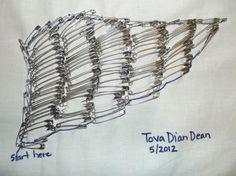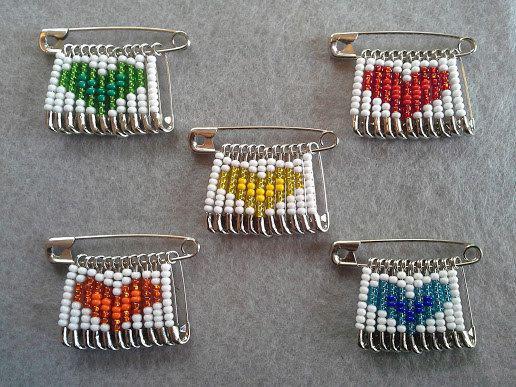The first image is the image on the left, the second image is the image on the right. Examine the images to the left and right. Is the description "One image contains a person wearing a black jacket with a bird design on it." accurate? Answer yes or no. No. The first image is the image on the left, the second image is the image on the right. For the images displayed, is the sentence "A woman models the back of a jacket decorated with pins in the shape of a complete bird." factually correct? Answer yes or no. No. 